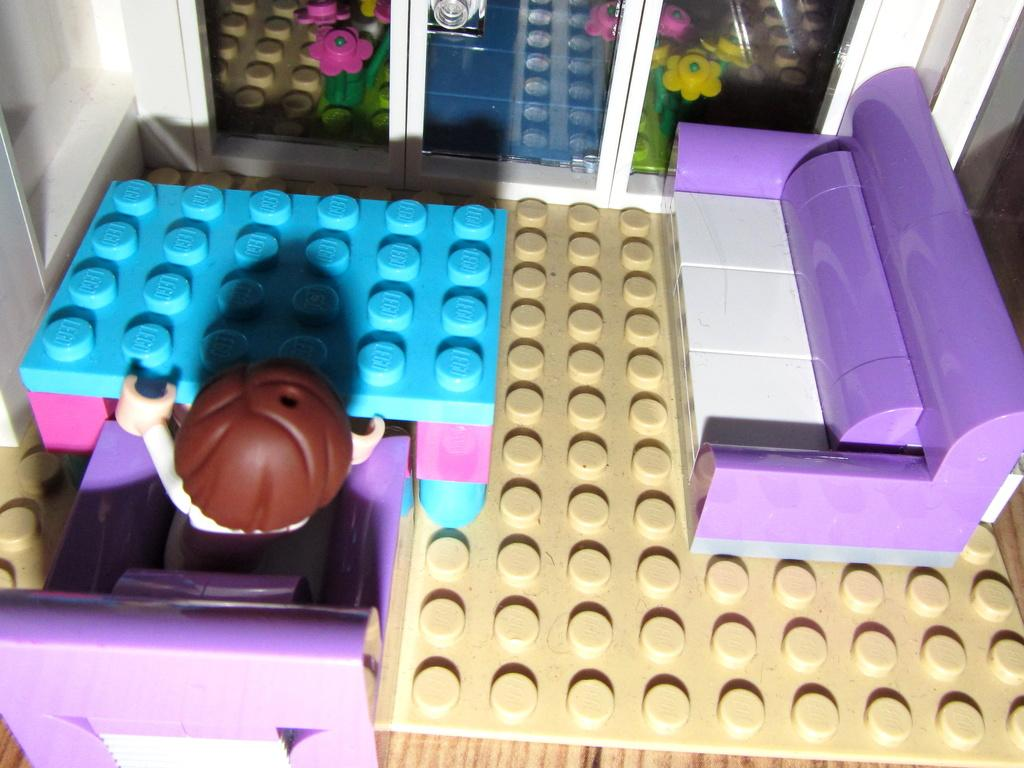What type of game is depicted in the image? The image contains a block fitting game. What are the components of the game? There are different toys in the toys in the game. What type of soup is being served in the image? There is no soup present in the image; it features a block fitting game with different toys. What part of the brain is visible in the image? There is no brain visible in the image; it features a block fitting game with different toys. 